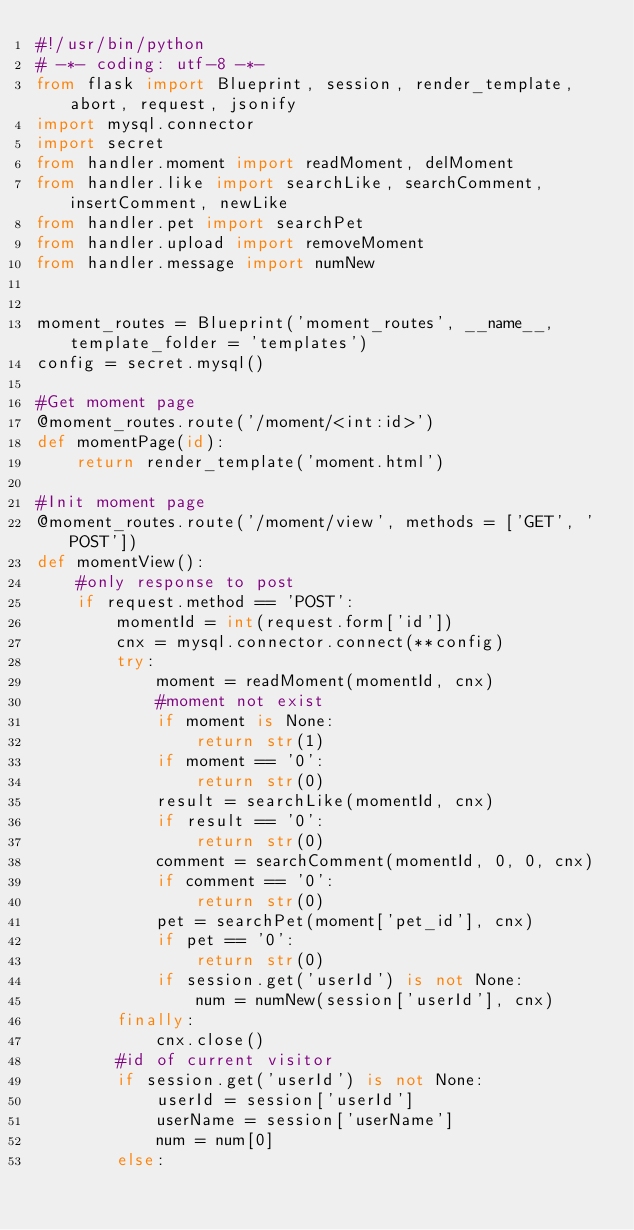Convert code to text. <code><loc_0><loc_0><loc_500><loc_500><_Python_>#!/usr/bin/python
# -*- coding: utf-8 -*-
from flask import Blueprint, session, render_template, abort, request, jsonify
import mysql.connector
import secret
from handler.moment import readMoment, delMoment
from handler.like import searchLike, searchComment, insertComment, newLike
from handler.pet import searchPet
from handler.upload import removeMoment
from handler.message import numNew


moment_routes = Blueprint('moment_routes', __name__, template_folder = 'templates')
config = secret.mysql()

#Get moment page
@moment_routes.route('/moment/<int:id>')
def momentPage(id):
    return render_template('moment.html')

#Init moment page
@moment_routes.route('/moment/view', methods = ['GET', 'POST'])
def momentView():
    #only response to post
    if request.method == 'POST':
        momentId = int(request.form['id'])
        cnx = mysql.connector.connect(**config)
        try:
            moment = readMoment(momentId, cnx)
            #moment not exist
            if moment is None:
                return str(1)
            if moment == '0':
                return str(0)
            result = searchLike(momentId, cnx)
            if result == '0':
                return str(0)
            comment = searchComment(momentId, 0, 0, cnx)
            if comment == '0':
                return str(0)
            pet = searchPet(moment['pet_id'], cnx)
            if pet == '0':
                return str(0)
            if session.get('userId') is not None:
                num = numNew(session['userId'], cnx)
        finally:
            cnx.close()
        #id of current visitor
        if session.get('userId') is not None:
            userId = session['userId']
            userName = session['userName']
            num = num[0]
        else:</code> 